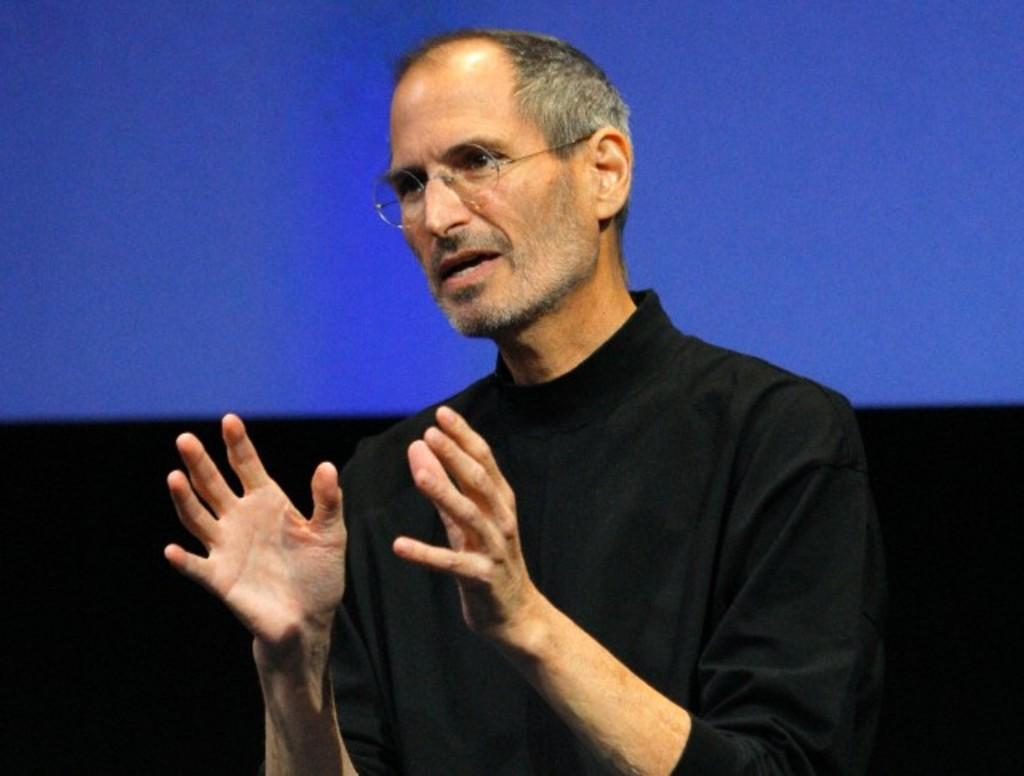Who or what is the main subject in the image? There is a person in the center of the image. What can be seen in the background of the image? There is a screen in the background of the image. What type of glass is the person holding in the image? There is no glass present in the image; the person is not holding anything. 